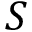Convert formula to latex. <formula><loc_0><loc_0><loc_500><loc_500>S</formula> 